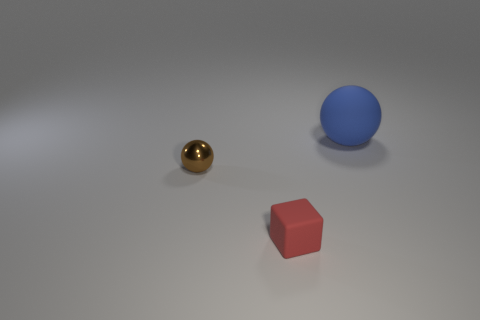The object that is on the right side of the tiny brown object and behind the small red object has what shape?
Offer a terse response. Sphere. How many things are small objects that are behind the red object or spheres that are in front of the big blue thing?
Ensure brevity in your answer.  1. What number of other objects are the same size as the red matte cube?
Give a very brief answer. 1. There is a sphere left of the large blue rubber object; is it the same color as the big object?
Make the answer very short. No. There is a object that is right of the small shiny thing and to the left of the large sphere; how big is it?
Your response must be concise. Small. What number of big objects are red things or blue rubber cylinders?
Make the answer very short. 0. The small thing that is behind the tiny cube has what shape?
Provide a short and direct response. Sphere. What number of small blue matte cylinders are there?
Give a very brief answer. 0. Are the cube and the big blue ball made of the same material?
Give a very brief answer. Yes. Are there more blue rubber spheres in front of the big blue rubber ball than blue spheres?
Your response must be concise. No. 